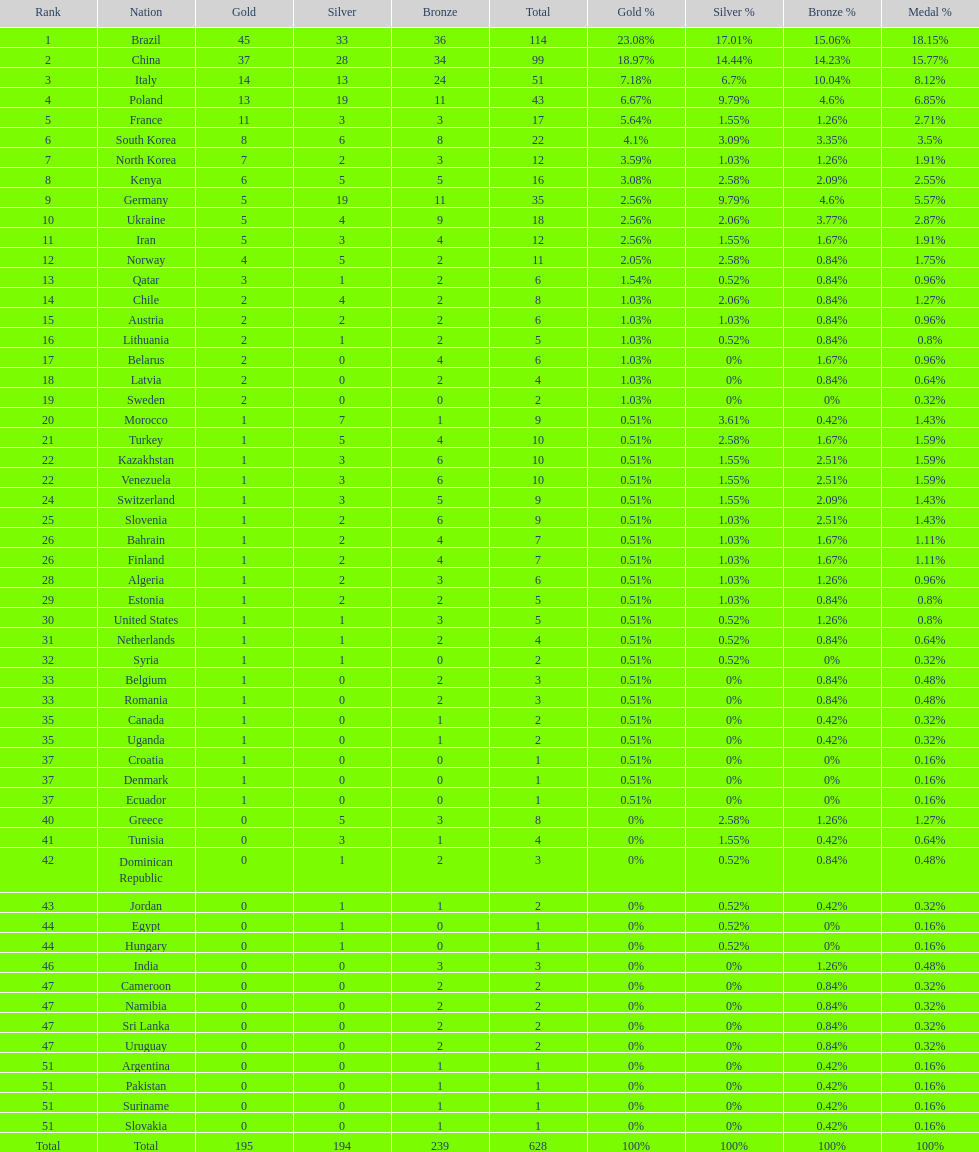Did italy or norway have 51 total medals? Italy. 